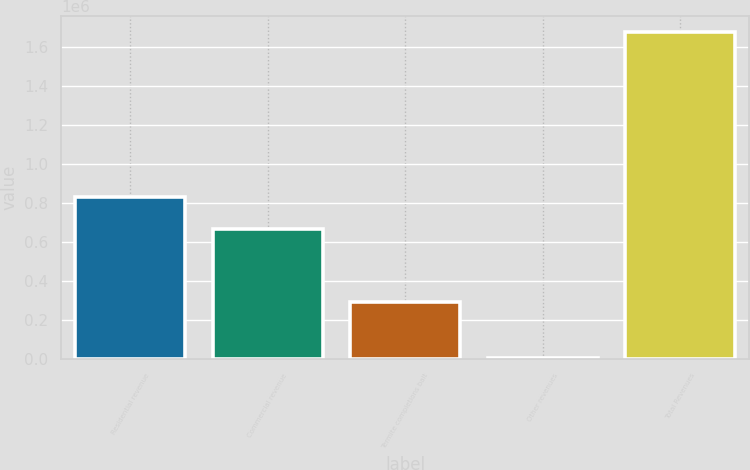Convert chart to OTSL. <chart><loc_0><loc_0><loc_500><loc_500><bar_chart><fcel>Residential revenue<fcel>Commercial revenue<fcel>Termite completions bait<fcel>Other revenues<fcel>Total Revenues<nl><fcel>833252<fcel>666523<fcel>294982<fcel>6665<fcel>1.67396e+06<nl></chart> 